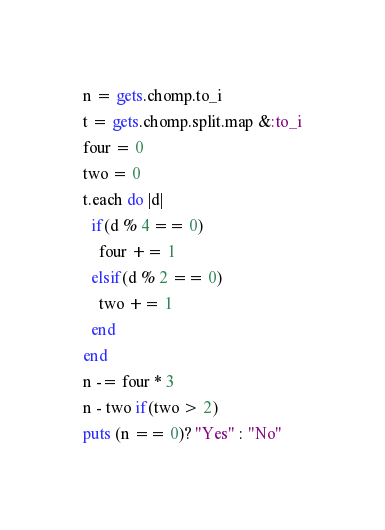<code> <loc_0><loc_0><loc_500><loc_500><_Ruby_>n = gets.chomp.to_i
t = gets.chomp.split.map &:to_i
four = 0
two = 0
t.each do |d|
  if(d % 4 == 0)
    four += 1 
  elsif(d % 2 == 0)
    two += 1
  end
end
n -= four * 3
n - two if(two > 2)
puts (n == 0)? "Yes" : "No"</code> 